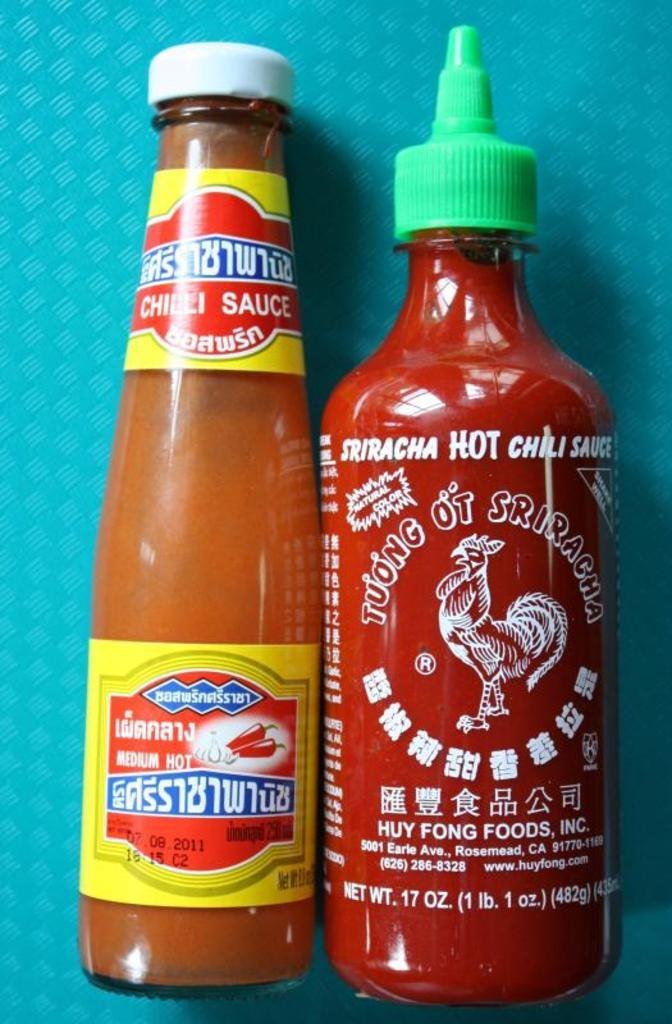<image>
Write a terse but informative summary of the picture. A chili sauce bottle sits next to another bottle for sriracha hot chili sauce. 